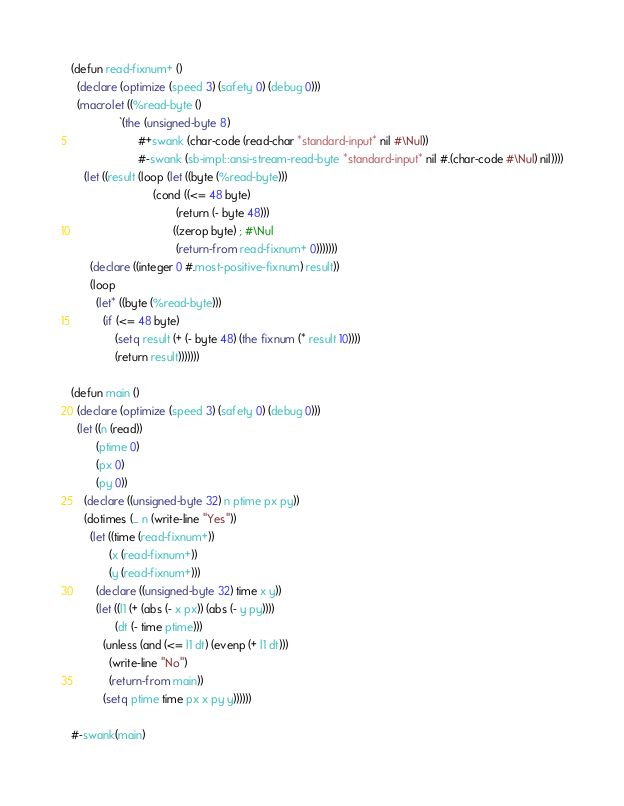Convert code to text. <code><loc_0><loc_0><loc_500><loc_500><_Lisp_>(defun read-fixnum+ ()
  (declare (optimize (speed 3) (safety 0) (debug 0)))
  (macrolet ((%read-byte ()
               `(the (unsigned-byte 8)
                     #+swank (char-code (read-char *standard-input* nil #\Nul))
                     #-swank (sb-impl::ansi-stream-read-byte *standard-input* nil #.(char-code #\Nul) nil))))
    (let ((result (loop (let ((byte (%read-byte)))
                          (cond ((<= 48 byte)
                                 (return (- byte 48)))
                                ((zerop byte) ; #\Nul
                                 (return-from read-fixnum+ 0)))))))
      (declare ((integer 0 #.most-positive-fixnum) result))
      (loop
        (let* ((byte (%read-byte)))
          (if (<= 48 byte)
              (setq result (+ (- byte 48) (the fixnum (* result 10))))
              (return result)))))))

(defun main ()
  (declare (optimize (speed 3) (safety 0) (debug 0)))
  (let ((n (read))
        (ptime 0)
        (px 0)
        (py 0))
    (declare ((unsigned-byte 32) n ptime px py))
    (dotimes (_ n (write-line "Yes"))
      (let ((time (read-fixnum+))
            (x (read-fixnum+))
            (y (read-fixnum+)))
        (declare ((unsigned-byte 32) time x y))
        (let ((l1 (+ (abs (- x px)) (abs (- y py))))
              (dt (- time ptime)))
          (unless (and (<= l1 dt) (evenp (+ l1 dt)))
            (write-line "No")
            (return-from main))
          (setq ptime time px x py y))))))

#-swank(main)
</code> 